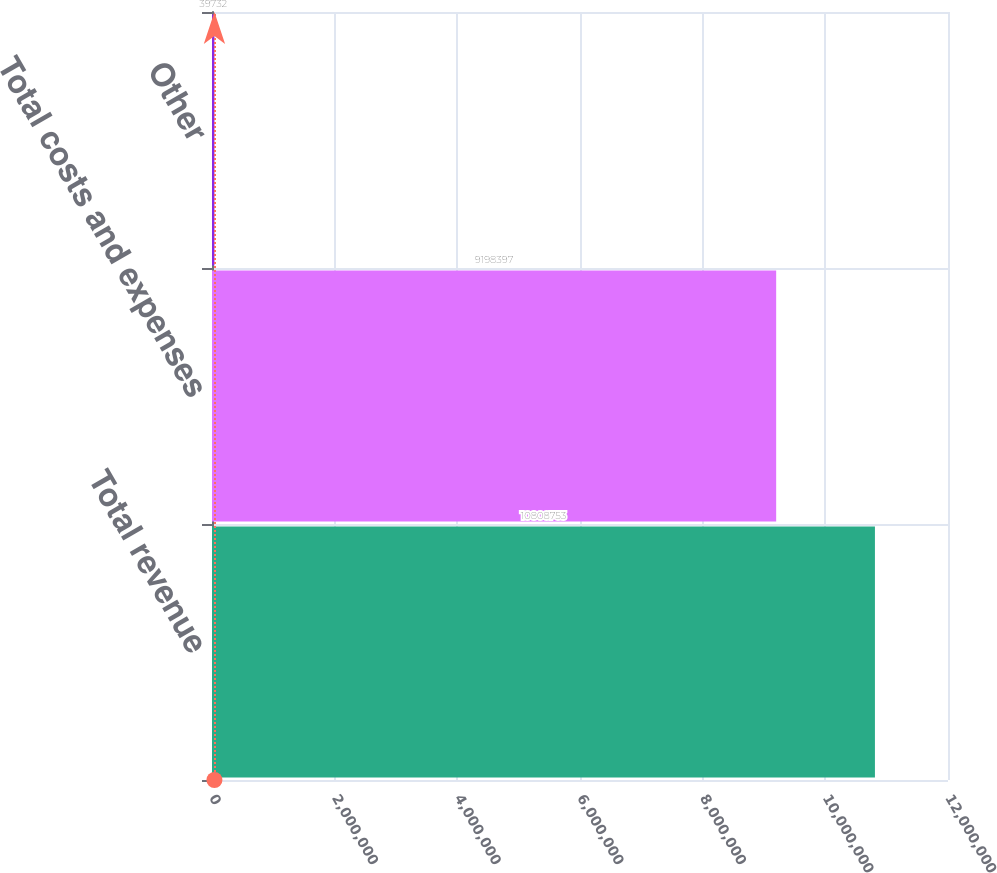Convert chart. <chart><loc_0><loc_0><loc_500><loc_500><bar_chart><fcel>Total revenue<fcel>Total costs and expenses<fcel>Other<nl><fcel>1.08088e+07<fcel>9.1984e+06<fcel>39732<nl></chart> 